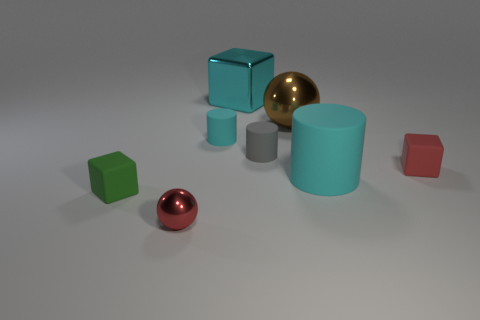Add 2 gray cylinders. How many objects exist? 10 Subtract all balls. How many objects are left? 6 Subtract all gray things. Subtract all red metallic things. How many objects are left? 6 Add 8 tiny green cubes. How many tiny green cubes are left? 9 Add 5 green blocks. How many green blocks exist? 6 Subtract 1 red balls. How many objects are left? 7 